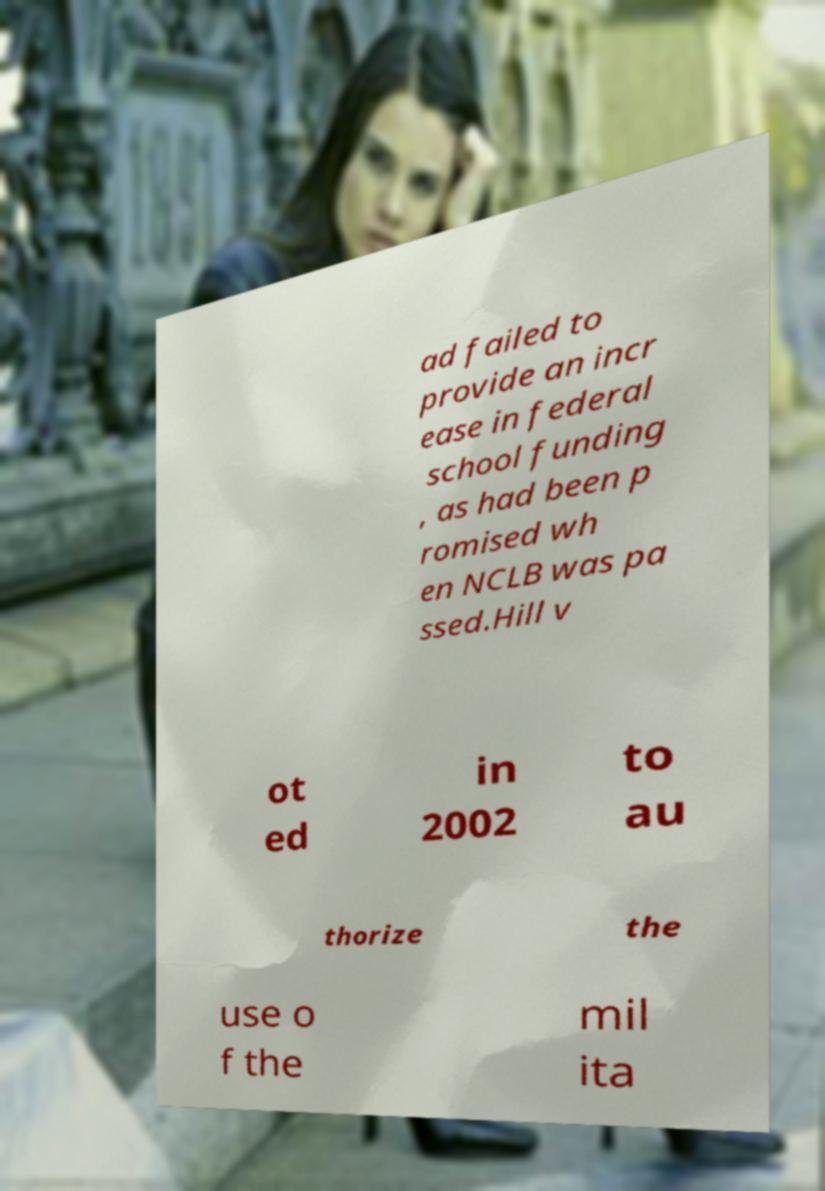Please identify and transcribe the text found in this image. ad failed to provide an incr ease in federal school funding , as had been p romised wh en NCLB was pa ssed.Hill v ot ed in 2002 to au thorize the use o f the mil ita 